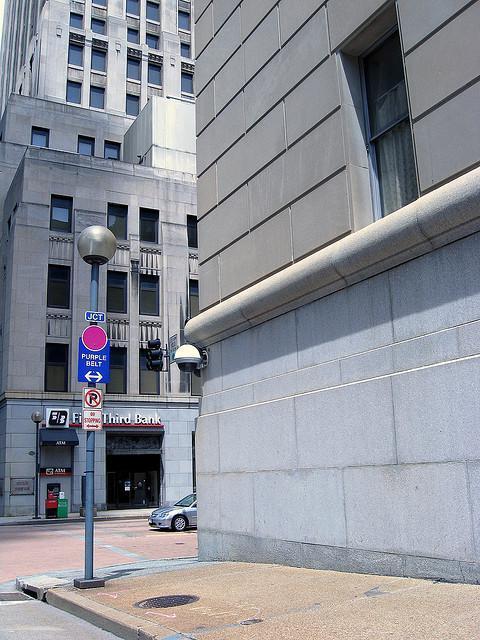How many people are in the photo?
Give a very brief answer. 0. How many people are on skis?
Give a very brief answer. 0. 